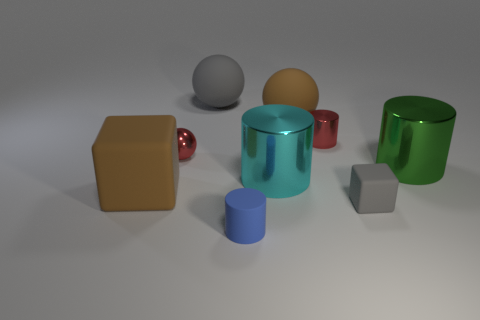How big is the brown matte thing behind the large block behind the gray rubber block?
Offer a very short reply. Large. There is a big rubber sphere to the right of the tiny matte cylinder; is its color the same as the tiny metal object that is on the left side of the rubber cylinder?
Provide a short and direct response. No. What color is the big rubber object that is both to the left of the brown matte ball and on the right side of the tiny red shiny sphere?
Offer a very short reply. Gray. How many other objects are there of the same shape as the large green thing?
Your response must be concise. 3. There is another sphere that is the same size as the brown matte sphere; what is its color?
Your answer should be compact. Gray. What is the color of the small metal thing to the right of the cyan thing?
Your answer should be compact. Red. Are there any tiny blue cylinders that are behind the gray object that is in front of the gray ball?
Offer a very short reply. No. There is a big cyan shiny thing; is its shape the same as the matte object that is in front of the small gray thing?
Provide a succinct answer. Yes. There is a matte thing that is left of the small blue cylinder and in front of the large brown sphere; what is its size?
Keep it short and to the point. Large. Are there any small cubes that have the same material as the blue object?
Make the answer very short. Yes. 